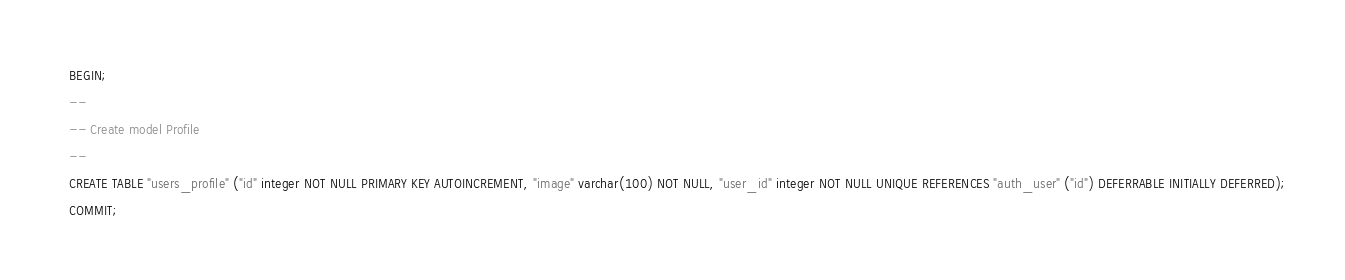Convert code to text. <code><loc_0><loc_0><loc_500><loc_500><_SQL_>BEGIN;
--
-- Create model Profile
--
CREATE TABLE "users_profile" ("id" integer NOT NULL PRIMARY KEY AUTOINCREMENT, "image" varchar(100) NOT NULL, "user_id" integer NOT NULL UNIQUE REFERENCES "auth_user" ("id") DEFERRABLE INITIALLY DEFERRED);
COMMIT;
</code> 